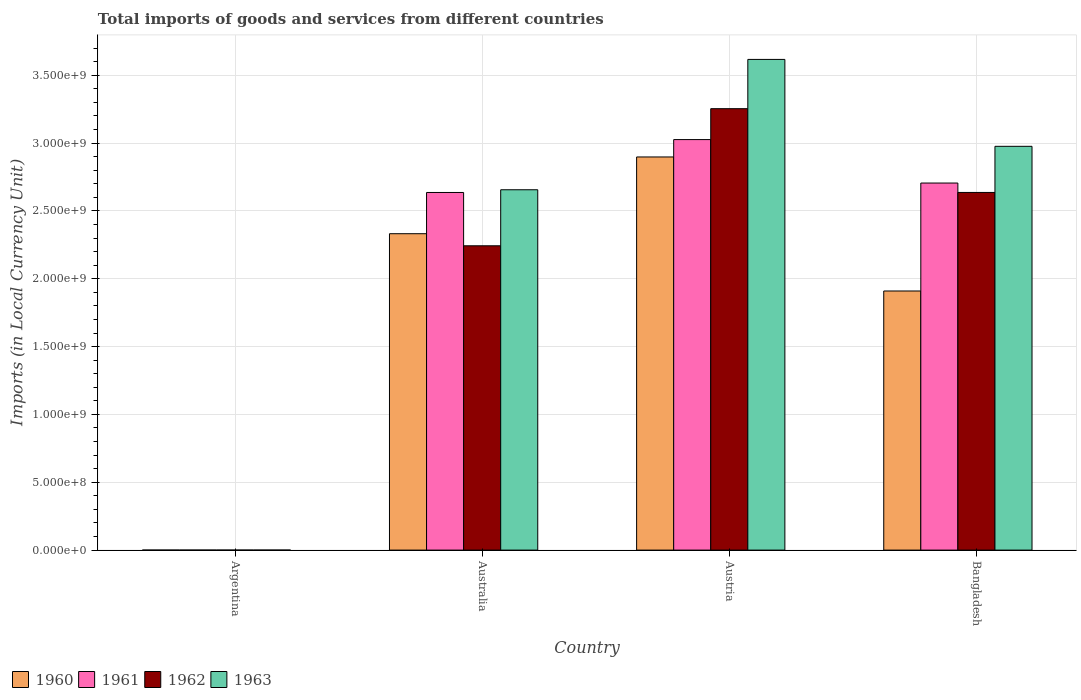How many different coloured bars are there?
Give a very brief answer. 4. Are the number of bars per tick equal to the number of legend labels?
Provide a succinct answer. Yes. What is the Amount of goods and services imports in 1963 in Australia?
Your answer should be compact. 2.66e+09. Across all countries, what is the maximum Amount of goods and services imports in 1963?
Provide a short and direct response. 3.62e+09. Across all countries, what is the minimum Amount of goods and services imports in 1961?
Your answer should be very brief. 0.01. In which country was the Amount of goods and services imports in 1961 maximum?
Your response must be concise. Austria. What is the total Amount of goods and services imports in 1962 in the graph?
Offer a very short reply. 8.13e+09. What is the difference between the Amount of goods and services imports in 1963 in Argentina and that in Australia?
Keep it short and to the point. -2.66e+09. What is the difference between the Amount of goods and services imports in 1961 in Argentina and the Amount of goods and services imports in 1962 in Bangladesh?
Make the answer very short. -2.64e+09. What is the average Amount of goods and services imports in 1962 per country?
Provide a short and direct response. 2.03e+09. In how many countries, is the Amount of goods and services imports in 1963 greater than 1600000000 LCU?
Your answer should be compact. 3. What is the ratio of the Amount of goods and services imports in 1961 in Argentina to that in Bangladesh?
Your answer should be very brief. 3.696102116502693e-12. What is the difference between the highest and the second highest Amount of goods and services imports in 1961?
Provide a succinct answer. 3.90e+08. What is the difference between the highest and the lowest Amount of goods and services imports in 1961?
Offer a very short reply. 3.03e+09. Is it the case that in every country, the sum of the Amount of goods and services imports in 1963 and Amount of goods and services imports in 1962 is greater than the sum of Amount of goods and services imports in 1960 and Amount of goods and services imports in 1961?
Your answer should be very brief. No. What does the 4th bar from the left in Bangladesh represents?
Give a very brief answer. 1963. What does the 1st bar from the right in Austria represents?
Offer a terse response. 1963. How many bars are there?
Your response must be concise. 16. How many countries are there in the graph?
Give a very brief answer. 4. What is the difference between two consecutive major ticks on the Y-axis?
Make the answer very short. 5.00e+08. Does the graph contain grids?
Offer a very short reply. Yes. Where does the legend appear in the graph?
Give a very brief answer. Bottom left. What is the title of the graph?
Provide a short and direct response. Total imports of goods and services from different countries. What is the label or title of the X-axis?
Provide a short and direct response. Country. What is the label or title of the Y-axis?
Offer a terse response. Imports (in Local Currency Unit). What is the Imports (in Local Currency Unit) of 1960 in Argentina?
Ensure brevity in your answer.  0.01. What is the Imports (in Local Currency Unit) of 1961 in Argentina?
Provide a short and direct response. 0.01. What is the Imports (in Local Currency Unit) in 1962 in Argentina?
Your answer should be compact. 0.02. What is the Imports (in Local Currency Unit) of 1963 in Argentina?
Give a very brief answer. 0.02. What is the Imports (in Local Currency Unit) in 1960 in Australia?
Your answer should be compact. 2.33e+09. What is the Imports (in Local Currency Unit) of 1961 in Australia?
Your response must be concise. 2.64e+09. What is the Imports (in Local Currency Unit) in 1962 in Australia?
Your answer should be very brief. 2.24e+09. What is the Imports (in Local Currency Unit) of 1963 in Australia?
Your answer should be very brief. 2.66e+09. What is the Imports (in Local Currency Unit) of 1960 in Austria?
Provide a short and direct response. 2.90e+09. What is the Imports (in Local Currency Unit) of 1961 in Austria?
Offer a terse response. 3.03e+09. What is the Imports (in Local Currency Unit) in 1962 in Austria?
Offer a terse response. 3.25e+09. What is the Imports (in Local Currency Unit) in 1963 in Austria?
Provide a short and direct response. 3.62e+09. What is the Imports (in Local Currency Unit) in 1960 in Bangladesh?
Ensure brevity in your answer.  1.91e+09. What is the Imports (in Local Currency Unit) of 1961 in Bangladesh?
Ensure brevity in your answer.  2.71e+09. What is the Imports (in Local Currency Unit) in 1962 in Bangladesh?
Make the answer very short. 2.64e+09. What is the Imports (in Local Currency Unit) in 1963 in Bangladesh?
Offer a very short reply. 2.98e+09. Across all countries, what is the maximum Imports (in Local Currency Unit) of 1960?
Keep it short and to the point. 2.90e+09. Across all countries, what is the maximum Imports (in Local Currency Unit) of 1961?
Your answer should be compact. 3.03e+09. Across all countries, what is the maximum Imports (in Local Currency Unit) in 1962?
Provide a succinct answer. 3.25e+09. Across all countries, what is the maximum Imports (in Local Currency Unit) in 1963?
Give a very brief answer. 3.62e+09. Across all countries, what is the minimum Imports (in Local Currency Unit) of 1960?
Give a very brief answer. 0.01. Across all countries, what is the minimum Imports (in Local Currency Unit) of 1961?
Offer a very short reply. 0.01. Across all countries, what is the minimum Imports (in Local Currency Unit) in 1962?
Your response must be concise. 0.02. Across all countries, what is the minimum Imports (in Local Currency Unit) of 1963?
Offer a terse response. 0.02. What is the total Imports (in Local Currency Unit) of 1960 in the graph?
Offer a terse response. 7.14e+09. What is the total Imports (in Local Currency Unit) in 1961 in the graph?
Keep it short and to the point. 8.37e+09. What is the total Imports (in Local Currency Unit) of 1962 in the graph?
Offer a very short reply. 8.13e+09. What is the total Imports (in Local Currency Unit) of 1963 in the graph?
Your answer should be compact. 9.25e+09. What is the difference between the Imports (in Local Currency Unit) in 1960 in Argentina and that in Australia?
Provide a succinct answer. -2.33e+09. What is the difference between the Imports (in Local Currency Unit) in 1961 in Argentina and that in Australia?
Provide a short and direct response. -2.64e+09. What is the difference between the Imports (in Local Currency Unit) in 1962 in Argentina and that in Australia?
Ensure brevity in your answer.  -2.24e+09. What is the difference between the Imports (in Local Currency Unit) of 1963 in Argentina and that in Australia?
Your answer should be very brief. -2.66e+09. What is the difference between the Imports (in Local Currency Unit) of 1960 in Argentina and that in Austria?
Make the answer very short. -2.90e+09. What is the difference between the Imports (in Local Currency Unit) in 1961 in Argentina and that in Austria?
Offer a terse response. -3.03e+09. What is the difference between the Imports (in Local Currency Unit) in 1962 in Argentina and that in Austria?
Give a very brief answer. -3.25e+09. What is the difference between the Imports (in Local Currency Unit) of 1963 in Argentina and that in Austria?
Provide a short and direct response. -3.62e+09. What is the difference between the Imports (in Local Currency Unit) of 1960 in Argentina and that in Bangladesh?
Offer a very short reply. -1.91e+09. What is the difference between the Imports (in Local Currency Unit) of 1961 in Argentina and that in Bangladesh?
Offer a very short reply. -2.71e+09. What is the difference between the Imports (in Local Currency Unit) in 1962 in Argentina and that in Bangladesh?
Offer a terse response. -2.64e+09. What is the difference between the Imports (in Local Currency Unit) of 1963 in Argentina and that in Bangladesh?
Your answer should be compact. -2.98e+09. What is the difference between the Imports (in Local Currency Unit) in 1960 in Australia and that in Austria?
Your answer should be compact. -5.66e+08. What is the difference between the Imports (in Local Currency Unit) in 1961 in Australia and that in Austria?
Your answer should be compact. -3.90e+08. What is the difference between the Imports (in Local Currency Unit) in 1962 in Australia and that in Austria?
Your answer should be very brief. -1.01e+09. What is the difference between the Imports (in Local Currency Unit) in 1963 in Australia and that in Austria?
Give a very brief answer. -9.61e+08. What is the difference between the Imports (in Local Currency Unit) in 1960 in Australia and that in Bangladesh?
Keep it short and to the point. 4.22e+08. What is the difference between the Imports (in Local Currency Unit) in 1961 in Australia and that in Bangladesh?
Make the answer very short. -6.96e+07. What is the difference between the Imports (in Local Currency Unit) in 1962 in Australia and that in Bangladesh?
Keep it short and to the point. -3.93e+08. What is the difference between the Imports (in Local Currency Unit) in 1963 in Australia and that in Bangladesh?
Keep it short and to the point. -3.20e+08. What is the difference between the Imports (in Local Currency Unit) in 1960 in Austria and that in Bangladesh?
Ensure brevity in your answer.  9.88e+08. What is the difference between the Imports (in Local Currency Unit) of 1961 in Austria and that in Bangladesh?
Keep it short and to the point. 3.20e+08. What is the difference between the Imports (in Local Currency Unit) of 1962 in Austria and that in Bangladesh?
Ensure brevity in your answer.  6.18e+08. What is the difference between the Imports (in Local Currency Unit) in 1963 in Austria and that in Bangladesh?
Make the answer very short. 6.41e+08. What is the difference between the Imports (in Local Currency Unit) in 1960 in Argentina and the Imports (in Local Currency Unit) in 1961 in Australia?
Offer a very short reply. -2.64e+09. What is the difference between the Imports (in Local Currency Unit) of 1960 in Argentina and the Imports (in Local Currency Unit) of 1962 in Australia?
Provide a succinct answer. -2.24e+09. What is the difference between the Imports (in Local Currency Unit) of 1960 in Argentina and the Imports (in Local Currency Unit) of 1963 in Australia?
Provide a succinct answer. -2.66e+09. What is the difference between the Imports (in Local Currency Unit) in 1961 in Argentina and the Imports (in Local Currency Unit) in 1962 in Australia?
Provide a short and direct response. -2.24e+09. What is the difference between the Imports (in Local Currency Unit) of 1961 in Argentina and the Imports (in Local Currency Unit) of 1963 in Australia?
Offer a terse response. -2.66e+09. What is the difference between the Imports (in Local Currency Unit) of 1962 in Argentina and the Imports (in Local Currency Unit) of 1963 in Australia?
Offer a terse response. -2.66e+09. What is the difference between the Imports (in Local Currency Unit) in 1960 in Argentina and the Imports (in Local Currency Unit) in 1961 in Austria?
Offer a very short reply. -3.03e+09. What is the difference between the Imports (in Local Currency Unit) in 1960 in Argentina and the Imports (in Local Currency Unit) in 1962 in Austria?
Keep it short and to the point. -3.25e+09. What is the difference between the Imports (in Local Currency Unit) of 1960 in Argentina and the Imports (in Local Currency Unit) of 1963 in Austria?
Keep it short and to the point. -3.62e+09. What is the difference between the Imports (in Local Currency Unit) in 1961 in Argentina and the Imports (in Local Currency Unit) in 1962 in Austria?
Offer a very short reply. -3.25e+09. What is the difference between the Imports (in Local Currency Unit) of 1961 in Argentina and the Imports (in Local Currency Unit) of 1963 in Austria?
Offer a very short reply. -3.62e+09. What is the difference between the Imports (in Local Currency Unit) in 1962 in Argentina and the Imports (in Local Currency Unit) in 1963 in Austria?
Your answer should be very brief. -3.62e+09. What is the difference between the Imports (in Local Currency Unit) in 1960 in Argentina and the Imports (in Local Currency Unit) in 1961 in Bangladesh?
Offer a very short reply. -2.71e+09. What is the difference between the Imports (in Local Currency Unit) in 1960 in Argentina and the Imports (in Local Currency Unit) in 1962 in Bangladesh?
Ensure brevity in your answer.  -2.64e+09. What is the difference between the Imports (in Local Currency Unit) of 1960 in Argentina and the Imports (in Local Currency Unit) of 1963 in Bangladesh?
Offer a very short reply. -2.98e+09. What is the difference between the Imports (in Local Currency Unit) of 1961 in Argentina and the Imports (in Local Currency Unit) of 1962 in Bangladesh?
Your answer should be compact. -2.64e+09. What is the difference between the Imports (in Local Currency Unit) in 1961 in Argentina and the Imports (in Local Currency Unit) in 1963 in Bangladesh?
Provide a short and direct response. -2.98e+09. What is the difference between the Imports (in Local Currency Unit) of 1962 in Argentina and the Imports (in Local Currency Unit) of 1963 in Bangladesh?
Provide a short and direct response. -2.98e+09. What is the difference between the Imports (in Local Currency Unit) in 1960 in Australia and the Imports (in Local Currency Unit) in 1961 in Austria?
Ensure brevity in your answer.  -6.94e+08. What is the difference between the Imports (in Local Currency Unit) in 1960 in Australia and the Imports (in Local Currency Unit) in 1962 in Austria?
Keep it short and to the point. -9.22e+08. What is the difference between the Imports (in Local Currency Unit) in 1960 in Australia and the Imports (in Local Currency Unit) in 1963 in Austria?
Give a very brief answer. -1.28e+09. What is the difference between the Imports (in Local Currency Unit) in 1961 in Australia and the Imports (in Local Currency Unit) in 1962 in Austria?
Provide a succinct answer. -6.18e+08. What is the difference between the Imports (in Local Currency Unit) of 1961 in Australia and the Imports (in Local Currency Unit) of 1963 in Austria?
Keep it short and to the point. -9.81e+08. What is the difference between the Imports (in Local Currency Unit) in 1962 in Australia and the Imports (in Local Currency Unit) in 1963 in Austria?
Provide a short and direct response. -1.37e+09. What is the difference between the Imports (in Local Currency Unit) in 1960 in Australia and the Imports (in Local Currency Unit) in 1961 in Bangladesh?
Offer a very short reply. -3.74e+08. What is the difference between the Imports (in Local Currency Unit) in 1960 in Australia and the Imports (in Local Currency Unit) in 1962 in Bangladesh?
Ensure brevity in your answer.  -3.04e+08. What is the difference between the Imports (in Local Currency Unit) of 1960 in Australia and the Imports (in Local Currency Unit) of 1963 in Bangladesh?
Offer a terse response. -6.44e+08. What is the difference between the Imports (in Local Currency Unit) of 1961 in Australia and the Imports (in Local Currency Unit) of 1962 in Bangladesh?
Keep it short and to the point. -1.80e+05. What is the difference between the Imports (in Local Currency Unit) of 1961 in Australia and the Imports (in Local Currency Unit) of 1963 in Bangladesh?
Your answer should be very brief. -3.40e+08. What is the difference between the Imports (in Local Currency Unit) of 1962 in Australia and the Imports (in Local Currency Unit) of 1963 in Bangladesh?
Make the answer very short. -7.33e+08. What is the difference between the Imports (in Local Currency Unit) in 1960 in Austria and the Imports (in Local Currency Unit) in 1961 in Bangladesh?
Your response must be concise. 1.92e+08. What is the difference between the Imports (in Local Currency Unit) of 1960 in Austria and the Imports (in Local Currency Unit) of 1962 in Bangladesh?
Provide a short and direct response. 2.62e+08. What is the difference between the Imports (in Local Currency Unit) of 1960 in Austria and the Imports (in Local Currency Unit) of 1963 in Bangladesh?
Give a very brief answer. -7.85e+07. What is the difference between the Imports (in Local Currency Unit) in 1961 in Austria and the Imports (in Local Currency Unit) in 1962 in Bangladesh?
Provide a succinct answer. 3.90e+08. What is the difference between the Imports (in Local Currency Unit) of 1961 in Austria and the Imports (in Local Currency Unit) of 1963 in Bangladesh?
Make the answer very short. 4.96e+07. What is the difference between the Imports (in Local Currency Unit) of 1962 in Austria and the Imports (in Local Currency Unit) of 1963 in Bangladesh?
Provide a short and direct response. 2.77e+08. What is the average Imports (in Local Currency Unit) of 1960 per country?
Offer a terse response. 1.78e+09. What is the average Imports (in Local Currency Unit) in 1961 per country?
Make the answer very short. 2.09e+09. What is the average Imports (in Local Currency Unit) of 1962 per country?
Offer a terse response. 2.03e+09. What is the average Imports (in Local Currency Unit) of 1963 per country?
Provide a short and direct response. 2.31e+09. What is the difference between the Imports (in Local Currency Unit) of 1960 and Imports (in Local Currency Unit) of 1961 in Argentina?
Provide a succinct answer. 0. What is the difference between the Imports (in Local Currency Unit) in 1960 and Imports (in Local Currency Unit) in 1962 in Argentina?
Keep it short and to the point. -0.01. What is the difference between the Imports (in Local Currency Unit) in 1960 and Imports (in Local Currency Unit) in 1963 in Argentina?
Provide a short and direct response. -0.01. What is the difference between the Imports (in Local Currency Unit) in 1961 and Imports (in Local Currency Unit) in 1962 in Argentina?
Your answer should be very brief. -0.01. What is the difference between the Imports (in Local Currency Unit) in 1961 and Imports (in Local Currency Unit) in 1963 in Argentina?
Your answer should be compact. -0.01. What is the difference between the Imports (in Local Currency Unit) of 1962 and Imports (in Local Currency Unit) of 1963 in Argentina?
Your answer should be very brief. 0. What is the difference between the Imports (in Local Currency Unit) in 1960 and Imports (in Local Currency Unit) in 1961 in Australia?
Provide a short and direct response. -3.04e+08. What is the difference between the Imports (in Local Currency Unit) in 1960 and Imports (in Local Currency Unit) in 1962 in Australia?
Your answer should be very brief. 8.90e+07. What is the difference between the Imports (in Local Currency Unit) in 1960 and Imports (in Local Currency Unit) in 1963 in Australia?
Make the answer very short. -3.24e+08. What is the difference between the Imports (in Local Currency Unit) in 1961 and Imports (in Local Currency Unit) in 1962 in Australia?
Offer a very short reply. 3.93e+08. What is the difference between the Imports (in Local Currency Unit) in 1961 and Imports (in Local Currency Unit) in 1963 in Australia?
Your response must be concise. -2.00e+07. What is the difference between the Imports (in Local Currency Unit) of 1962 and Imports (in Local Currency Unit) of 1963 in Australia?
Provide a short and direct response. -4.13e+08. What is the difference between the Imports (in Local Currency Unit) in 1960 and Imports (in Local Currency Unit) in 1961 in Austria?
Provide a short and direct response. -1.28e+08. What is the difference between the Imports (in Local Currency Unit) of 1960 and Imports (in Local Currency Unit) of 1962 in Austria?
Your response must be concise. -3.56e+08. What is the difference between the Imports (in Local Currency Unit) of 1960 and Imports (in Local Currency Unit) of 1963 in Austria?
Your answer should be compact. -7.19e+08. What is the difference between the Imports (in Local Currency Unit) in 1961 and Imports (in Local Currency Unit) in 1962 in Austria?
Ensure brevity in your answer.  -2.28e+08. What is the difference between the Imports (in Local Currency Unit) in 1961 and Imports (in Local Currency Unit) in 1963 in Austria?
Provide a succinct answer. -5.91e+08. What is the difference between the Imports (in Local Currency Unit) in 1962 and Imports (in Local Currency Unit) in 1963 in Austria?
Keep it short and to the point. -3.63e+08. What is the difference between the Imports (in Local Currency Unit) in 1960 and Imports (in Local Currency Unit) in 1961 in Bangladesh?
Your response must be concise. -7.96e+08. What is the difference between the Imports (in Local Currency Unit) of 1960 and Imports (in Local Currency Unit) of 1962 in Bangladesh?
Make the answer very short. -7.26e+08. What is the difference between the Imports (in Local Currency Unit) in 1960 and Imports (in Local Currency Unit) in 1963 in Bangladesh?
Make the answer very short. -1.07e+09. What is the difference between the Imports (in Local Currency Unit) of 1961 and Imports (in Local Currency Unit) of 1962 in Bangladesh?
Provide a succinct answer. 6.94e+07. What is the difference between the Imports (in Local Currency Unit) in 1961 and Imports (in Local Currency Unit) in 1963 in Bangladesh?
Keep it short and to the point. -2.71e+08. What is the difference between the Imports (in Local Currency Unit) of 1962 and Imports (in Local Currency Unit) of 1963 in Bangladesh?
Ensure brevity in your answer.  -3.40e+08. What is the ratio of the Imports (in Local Currency Unit) in 1960 in Argentina to that in Australia?
Your response must be concise. 0. What is the ratio of the Imports (in Local Currency Unit) of 1961 in Argentina to that in Australia?
Ensure brevity in your answer.  0. What is the ratio of the Imports (in Local Currency Unit) in 1962 in Argentina to that in Australia?
Provide a short and direct response. 0. What is the ratio of the Imports (in Local Currency Unit) in 1963 in Argentina to that in Australia?
Ensure brevity in your answer.  0. What is the ratio of the Imports (in Local Currency Unit) of 1963 in Argentina to that in Austria?
Your answer should be very brief. 0. What is the ratio of the Imports (in Local Currency Unit) in 1960 in Argentina to that in Bangladesh?
Your response must be concise. 0. What is the ratio of the Imports (in Local Currency Unit) in 1961 in Argentina to that in Bangladesh?
Your answer should be compact. 0. What is the ratio of the Imports (in Local Currency Unit) of 1963 in Argentina to that in Bangladesh?
Your response must be concise. 0. What is the ratio of the Imports (in Local Currency Unit) of 1960 in Australia to that in Austria?
Give a very brief answer. 0.8. What is the ratio of the Imports (in Local Currency Unit) of 1961 in Australia to that in Austria?
Your answer should be very brief. 0.87. What is the ratio of the Imports (in Local Currency Unit) of 1962 in Australia to that in Austria?
Keep it short and to the point. 0.69. What is the ratio of the Imports (in Local Currency Unit) of 1963 in Australia to that in Austria?
Your response must be concise. 0.73. What is the ratio of the Imports (in Local Currency Unit) in 1960 in Australia to that in Bangladesh?
Provide a short and direct response. 1.22. What is the ratio of the Imports (in Local Currency Unit) of 1961 in Australia to that in Bangladesh?
Offer a terse response. 0.97. What is the ratio of the Imports (in Local Currency Unit) in 1962 in Australia to that in Bangladesh?
Make the answer very short. 0.85. What is the ratio of the Imports (in Local Currency Unit) of 1963 in Australia to that in Bangladesh?
Ensure brevity in your answer.  0.89. What is the ratio of the Imports (in Local Currency Unit) of 1960 in Austria to that in Bangladesh?
Your response must be concise. 1.52. What is the ratio of the Imports (in Local Currency Unit) of 1961 in Austria to that in Bangladesh?
Make the answer very short. 1.12. What is the ratio of the Imports (in Local Currency Unit) in 1962 in Austria to that in Bangladesh?
Your answer should be compact. 1.23. What is the ratio of the Imports (in Local Currency Unit) of 1963 in Austria to that in Bangladesh?
Your answer should be compact. 1.22. What is the difference between the highest and the second highest Imports (in Local Currency Unit) in 1960?
Give a very brief answer. 5.66e+08. What is the difference between the highest and the second highest Imports (in Local Currency Unit) of 1961?
Your response must be concise. 3.20e+08. What is the difference between the highest and the second highest Imports (in Local Currency Unit) of 1962?
Give a very brief answer. 6.18e+08. What is the difference between the highest and the second highest Imports (in Local Currency Unit) of 1963?
Keep it short and to the point. 6.41e+08. What is the difference between the highest and the lowest Imports (in Local Currency Unit) of 1960?
Ensure brevity in your answer.  2.90e+09. What is the difference between the highest and the lowest Imports (in Local Currency Unit) of 1961?
Ensure brevity in your answer.  3.03e+09. What is the difference between the highest and the lowest Imports (in Local Currency Unit) of 1962?
Keep it short and to the point. 3.25e+09. What is the difference between the highest and the lowest Imports (in Local Currency Unit) of 1963?
Provide a short and direct response. 3.62e+09. 